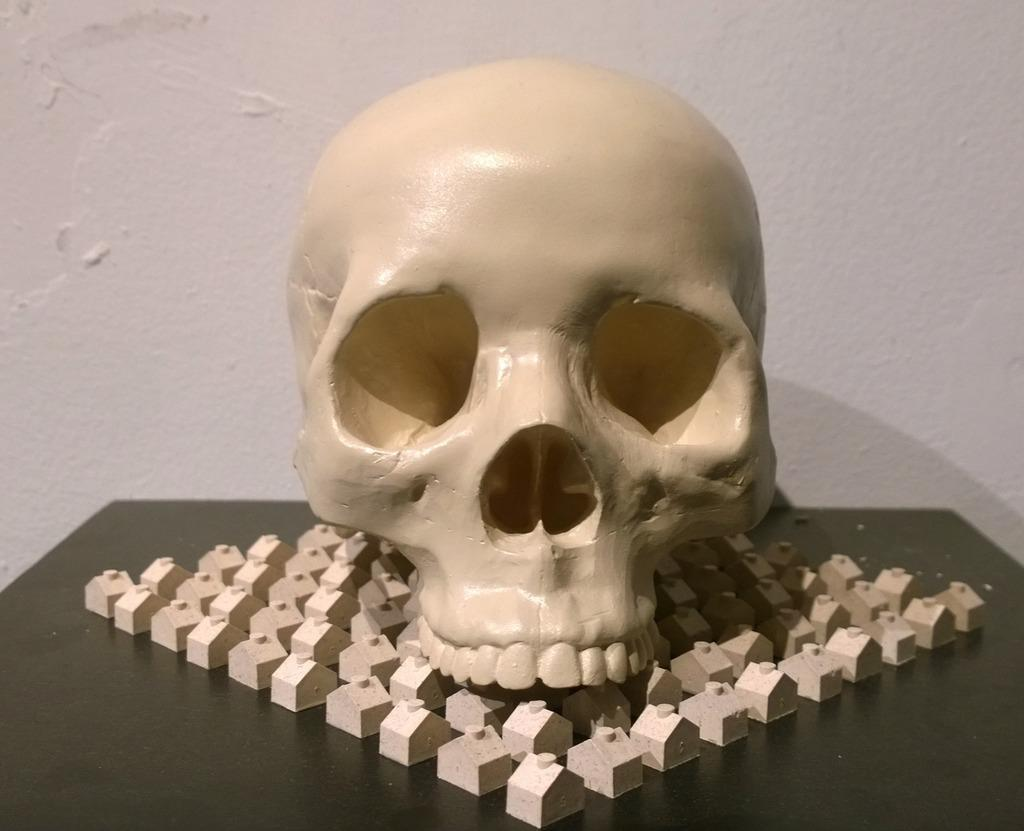What is the main subject of the image? There is a skull in the image. What else can be seen on the table in the image? There are blocks on the table in the image. What is visible in the background of the image? The background of the image includes a wall. What type of pan is being used to cook the doll in the image? There is no pan or doll present in the image; it only features a skull and blocks on a table. 